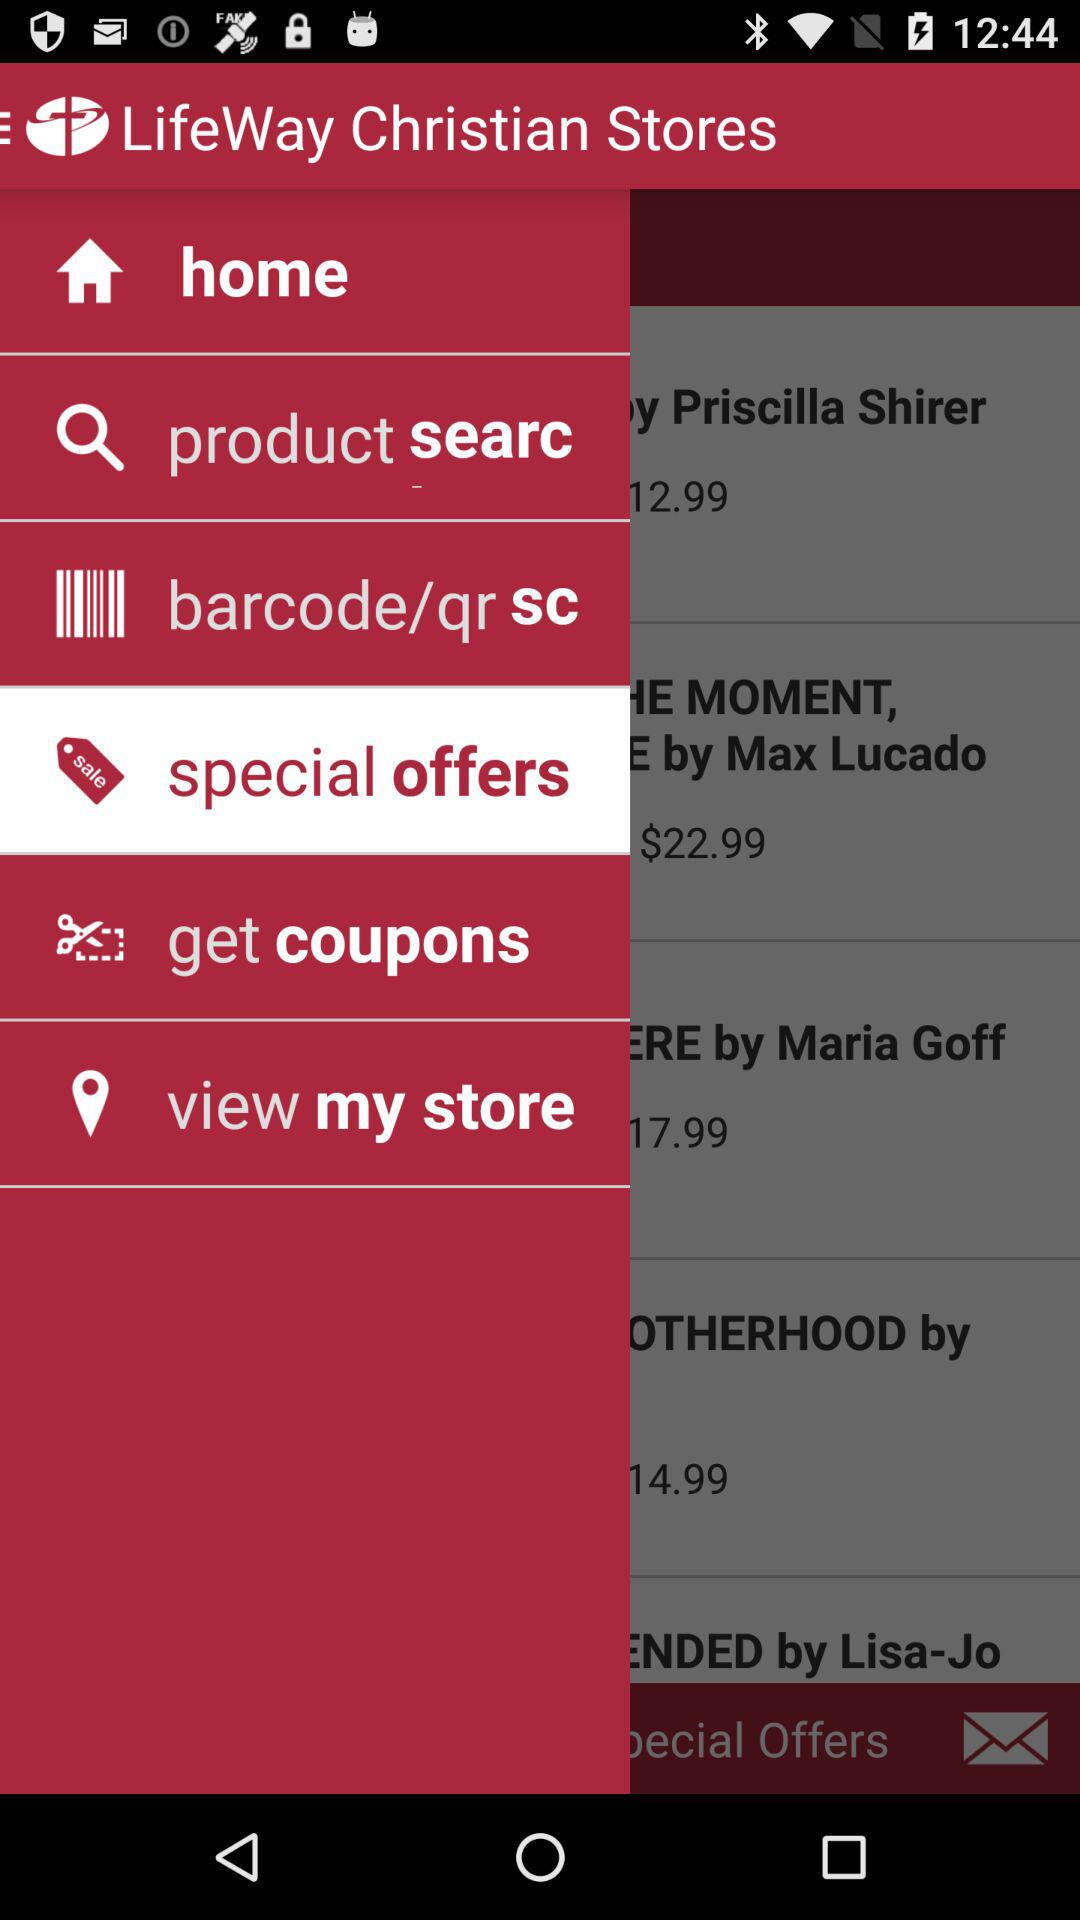What is the application name? The application name is "LifeWay Christian Stores". 